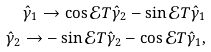<formula> <loc_0><loc_0><loc_500><loc_500>\hat { \gamma } _ { 1 } \rightarrow \cos \mathcal { E } T \hat { \gamma } _ { 2 } - \sin \mathcal { E } T \hat { \gamma } _ { 1 } \\ \hat { \gamma } _ { 2 } \rightarrow - \sin \mathcal { E } T \hat { \gamma } _ { 2 } - \cos \mathcal { E } T \hat { \gamma } _ { 1 } ,</formula> 